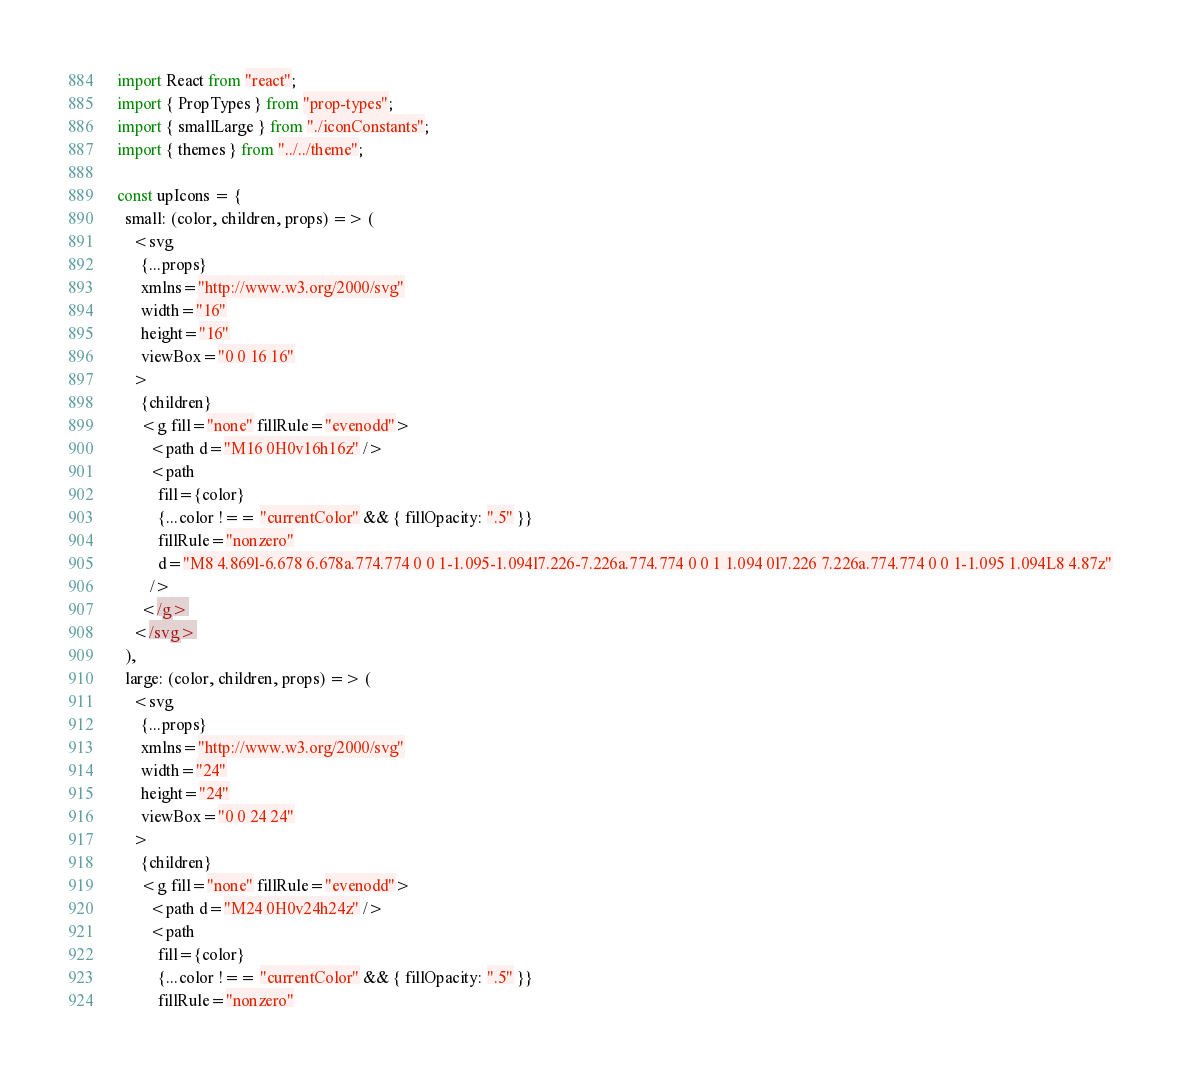Convert code to text. <code><loc_0><loc_0><loc_500><loc_500><_JavaScript_>import React from "react";
import { PropTypes } from "prop-types";
import { smallLarge } from "./iconConstants";
import { themes } from "../../theme";

const upIcons = {
  small: (color, children, props) => (
    <svg
      {...props}
      xmlns="http://www.w3.org/2000/svg"
      width="16"
      height="16"
      viewBox="0 0 16 16"
    >
      {children}
      <g fill="none" fillRule="evenodd">
        <path d="M16 0H0v16h16z" />
        <path
          fill={color}
          {...color !== "currentColor" && { fillOpacity: ".5" }}
          fillRule="nonzero"
          d="M8 4.869l-6.678 6.678a.774.774 0 0 1-1.095-1.094l7.226-7.226a.774.774 0 0 1 1.094 0l7.226 7.226a.774.774 0 0 1-1.095 1.094L8 4.87z"
        />
      </g>
    </svg>
  ),
  large: (color, children, props) => (
    <svg
      {...props}
      xmlns="http://www.w3.org/2000/svg"
      width="24"
      height="24"
      viewBox="0 0 24 24"
    >
      {children}
      <g fill="none" fillRule="evenodd">
        <path d="M24 0H0v24h24z" />
        <path
          fill={color}
          {...color !== "currentColor" && { fillOpacity: ".5" }}
          fillRule="nonzero"</code> 